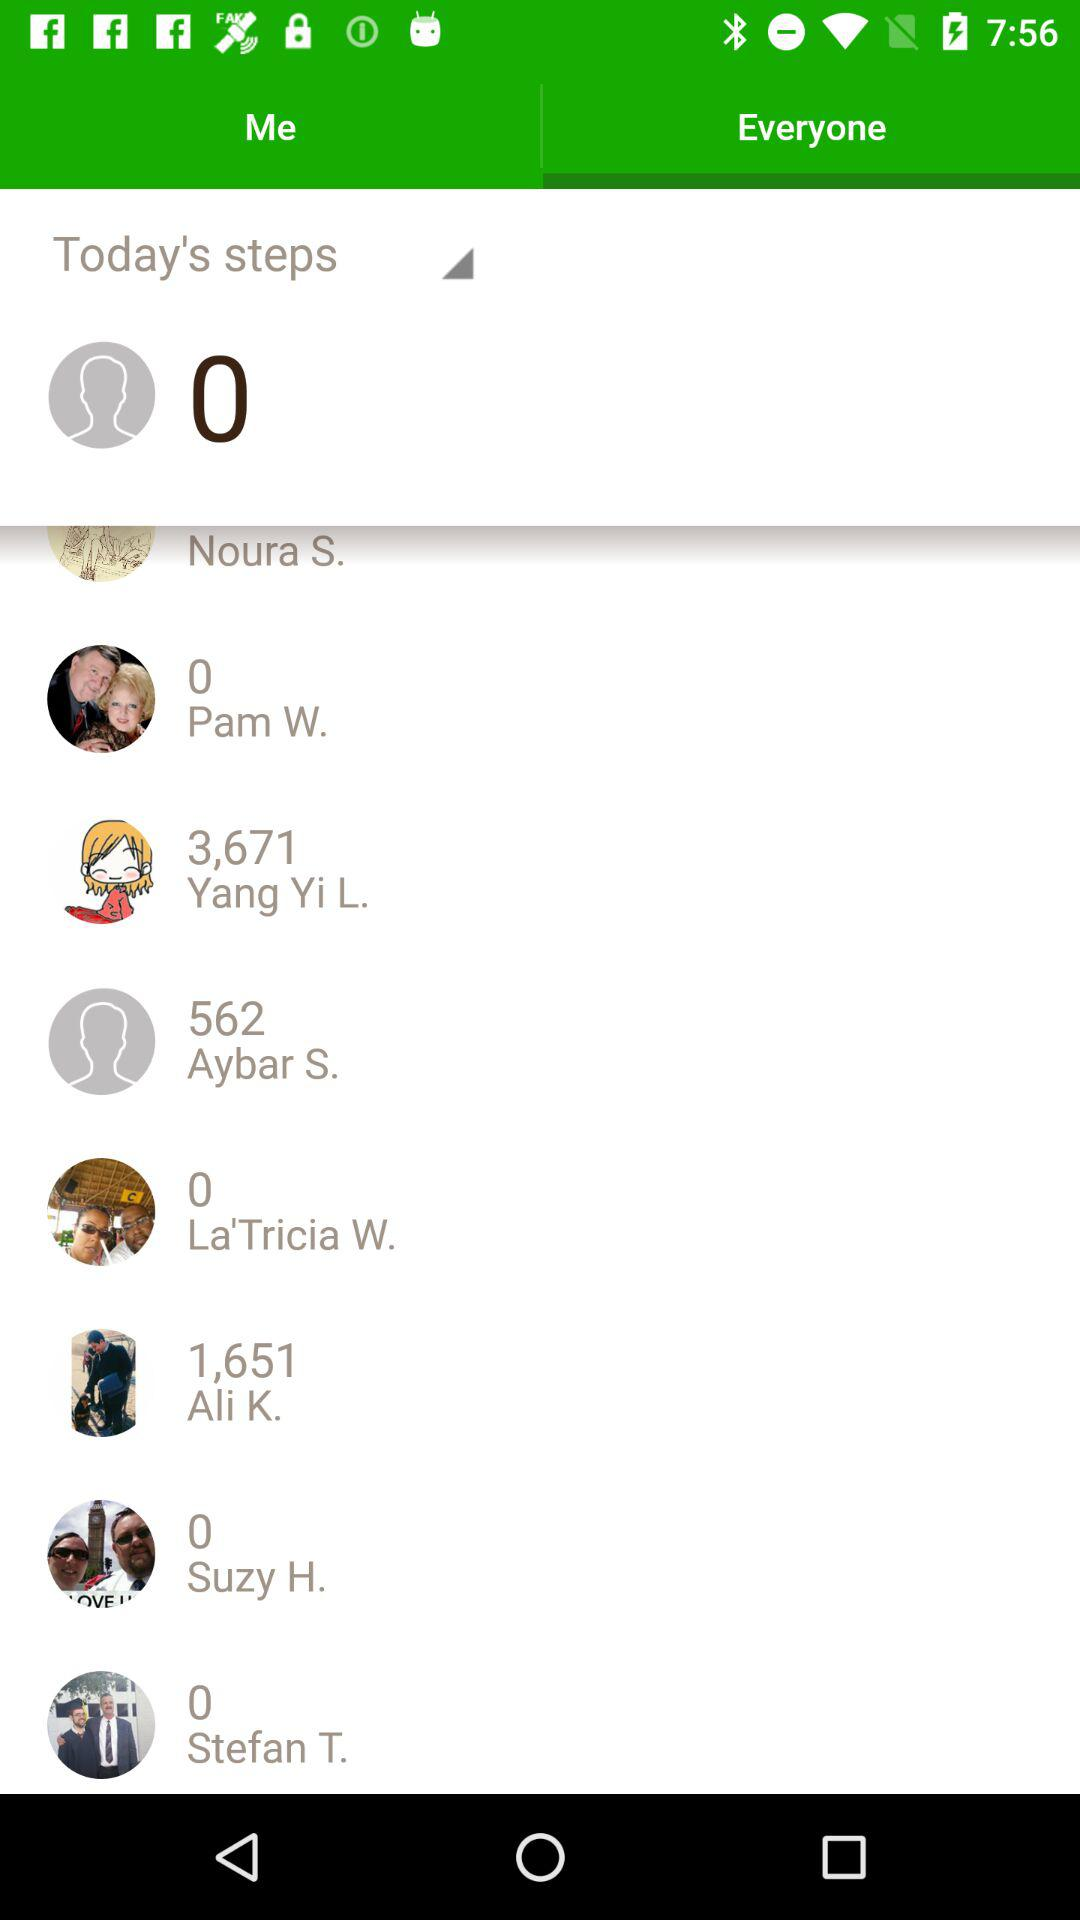Who has taken 562 steps? The person who took 562 steps is Aybar S. 